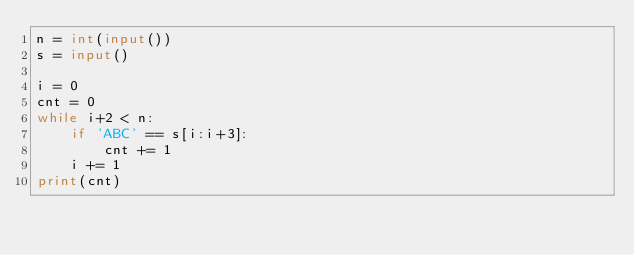<code> <loc_0><loc_0><loc_500><loc_500><_Python_>n = int(input())
s = input()

i = 0
cnt = 0
while i+2 < n:
    if 'ABC' == s[i:i+3]:
        cnt += 1
    i += 1
print(cnt)</code> 